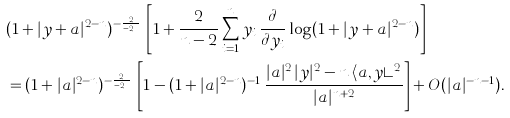<formula> <loc_0><loc_0><loc_500><loc_500>& ( 1 + | y + a | ^ { 2 - n } ) ^ { - \frac { 2 } { n - 2 } } \, \left [ 1 + \frac { 2 } { n - 2 } \sum _ { i = 1 } ^ { n } y _ { i } \, \frac { \partial } { \partial y _ { i } } \log ( 1 + | y + a | ^ { 2 - n } ) \right ] \\ & = ( 1 + | a | ^ { 2 - n } ) ^ { - \frac { 2 } { n - 2 } } \, \left [ 1 - ( 1 + | a | ^ { 2 - n } ) ^ { - 1 } \, \frac { | a | ^ { 2 } \, | y | ^ { 2 } - n \, \langle a , y \rangle ^ { 2 } } { | a | ^ { n + 2 } } \right ] + O ( | a | ^ { - n - 1 } ) .</formula> 